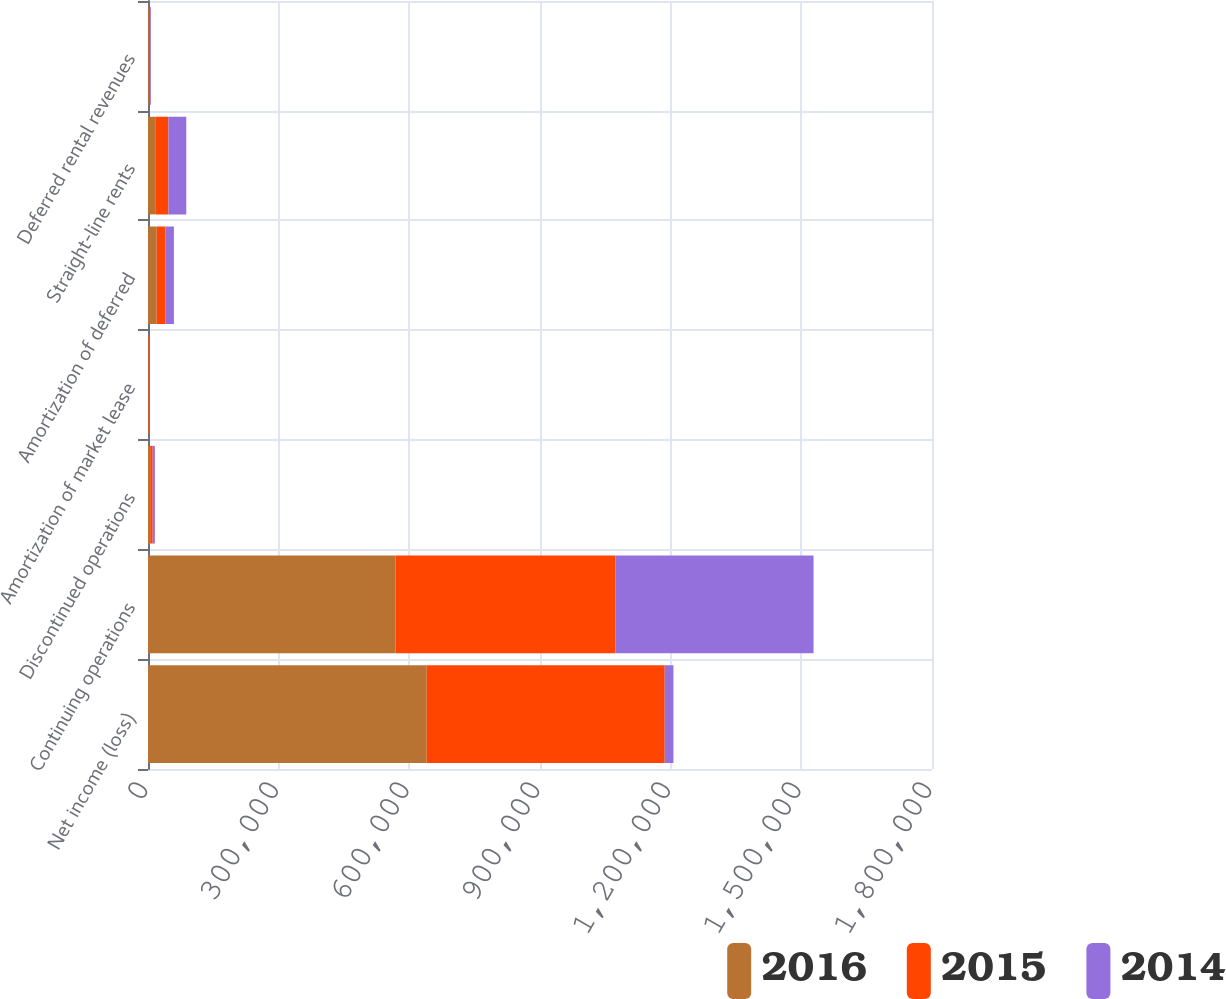<chart> <loc_0><loc_0><loc_500><loc_500><stacked_bar_chart><ecel><fcel>Net income (loss)<fcel>Continuing operations<fcel>Discontinued operations<fcel>Amortization of market lease<fcel>Amortization of deferred<fcel>Straight-line rents<fcel>Deferred rental revenues<nl><fcel>2016<fcel>639926<fcel>568108<fcel>4890<fcel>1197<fcel>20014<fcel>18003<fcel>1959<nl><fcel>2015<fcel>546418<fcel>504905<fcel>5880<fcel>1295<fcel>20222<fcel>28859<fcel>2813<nl><fcel>2014<fcel>20014<fcel>455016<fcel>4979<fcel>949<fcel>19260<fcel>41032<fcel>1884<nl></chart> 